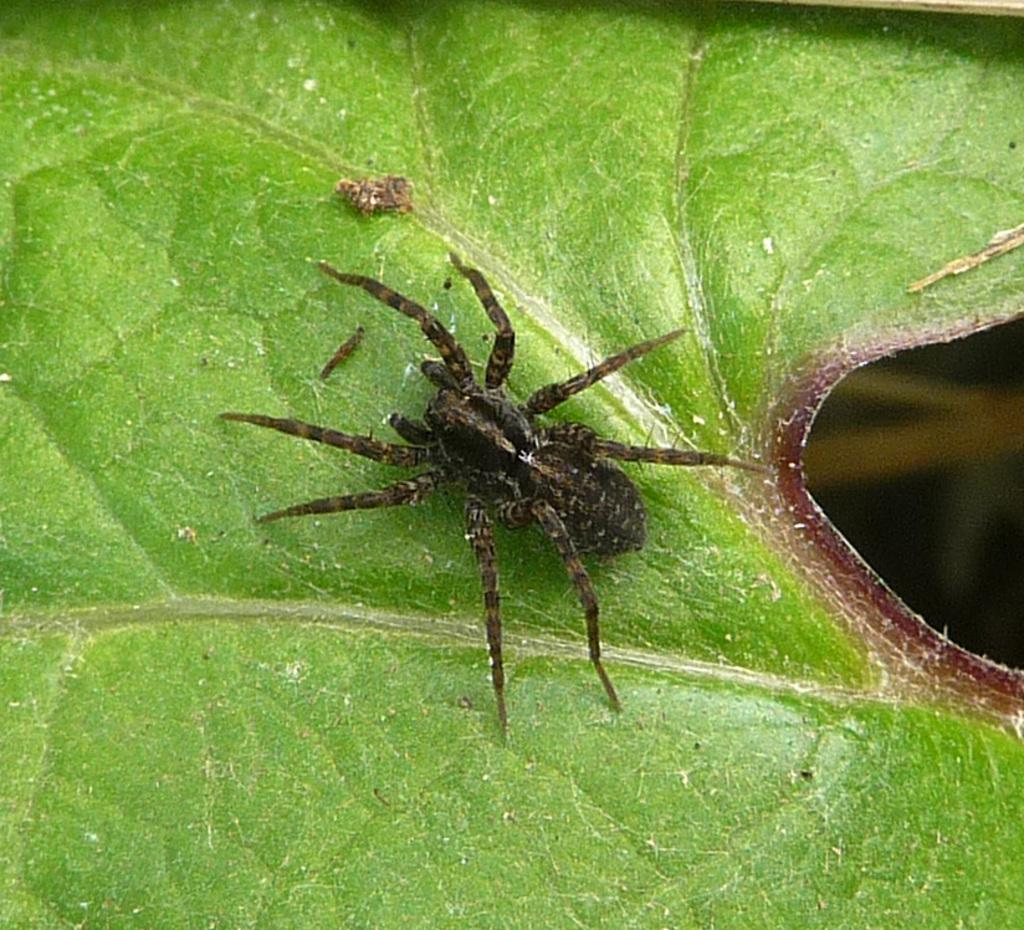What is the main subject of the image? There is a spider in the image. Where is the spider located? The spider is on a leaf. What type of chin can be seen on the spider in the image? Spiders do not have chins, so there is no chin visible on the spider in the image. 